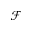<formula> <loc_0><loc_0><loc_500><loc_500>\mathcal { F }</formula> 